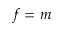Convert formula to latex. <formula><loc_0><loc_0><loc_500><loc_500>f = m</formula> 